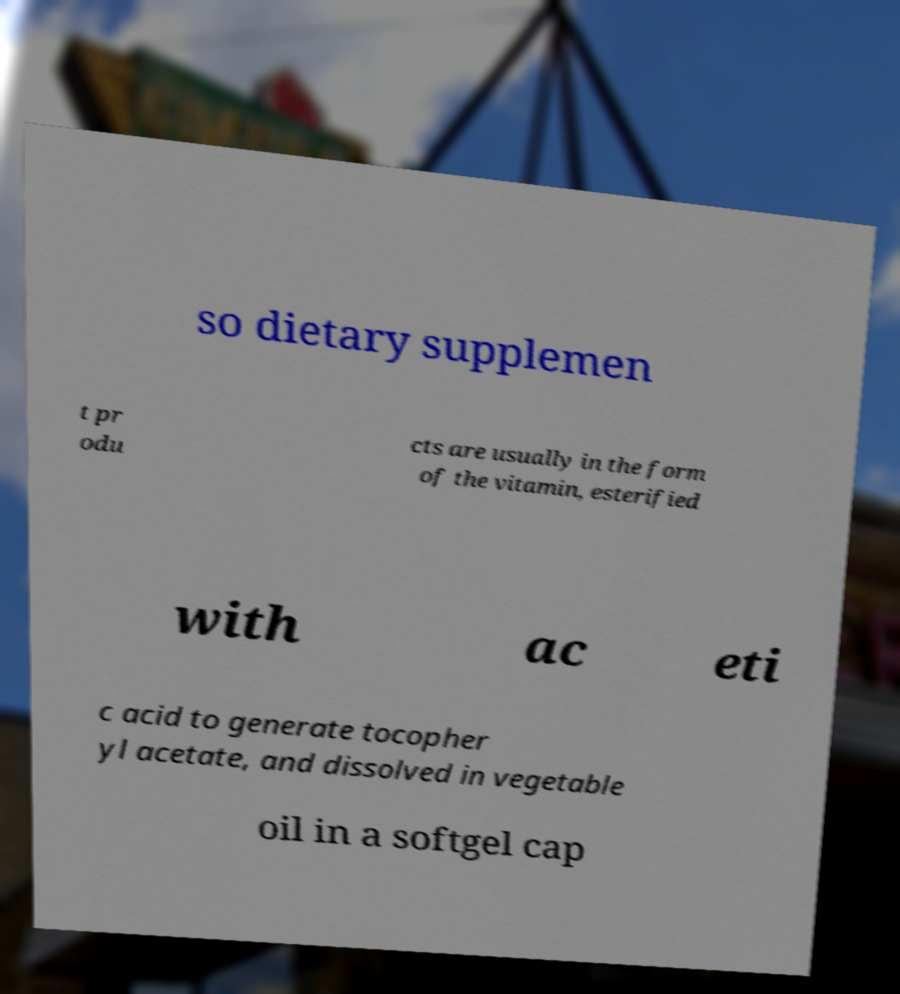Could you assist in decoding the text presented in this image and type it out clearly? so dietary supplemen t pr odu cts are usually in the form of the vitamin, esterified with ac eti c acid to generate tocopher yl acetate, and dissolved in vegetable oil in a softgel cap 